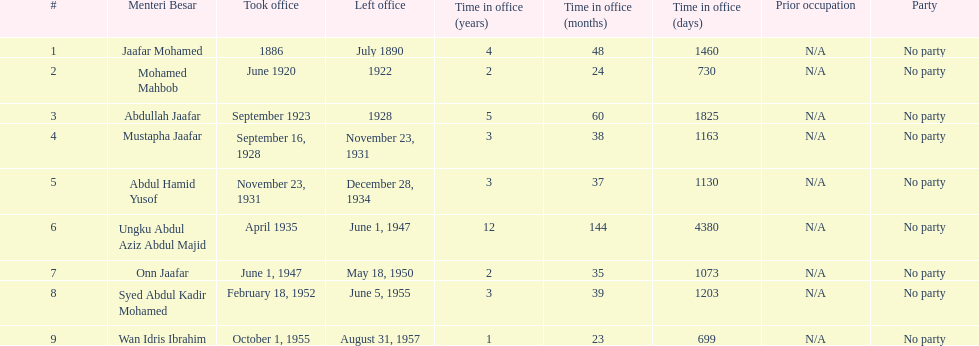What is the number of menteri besars that there have been during the pre-independence period? 9. 